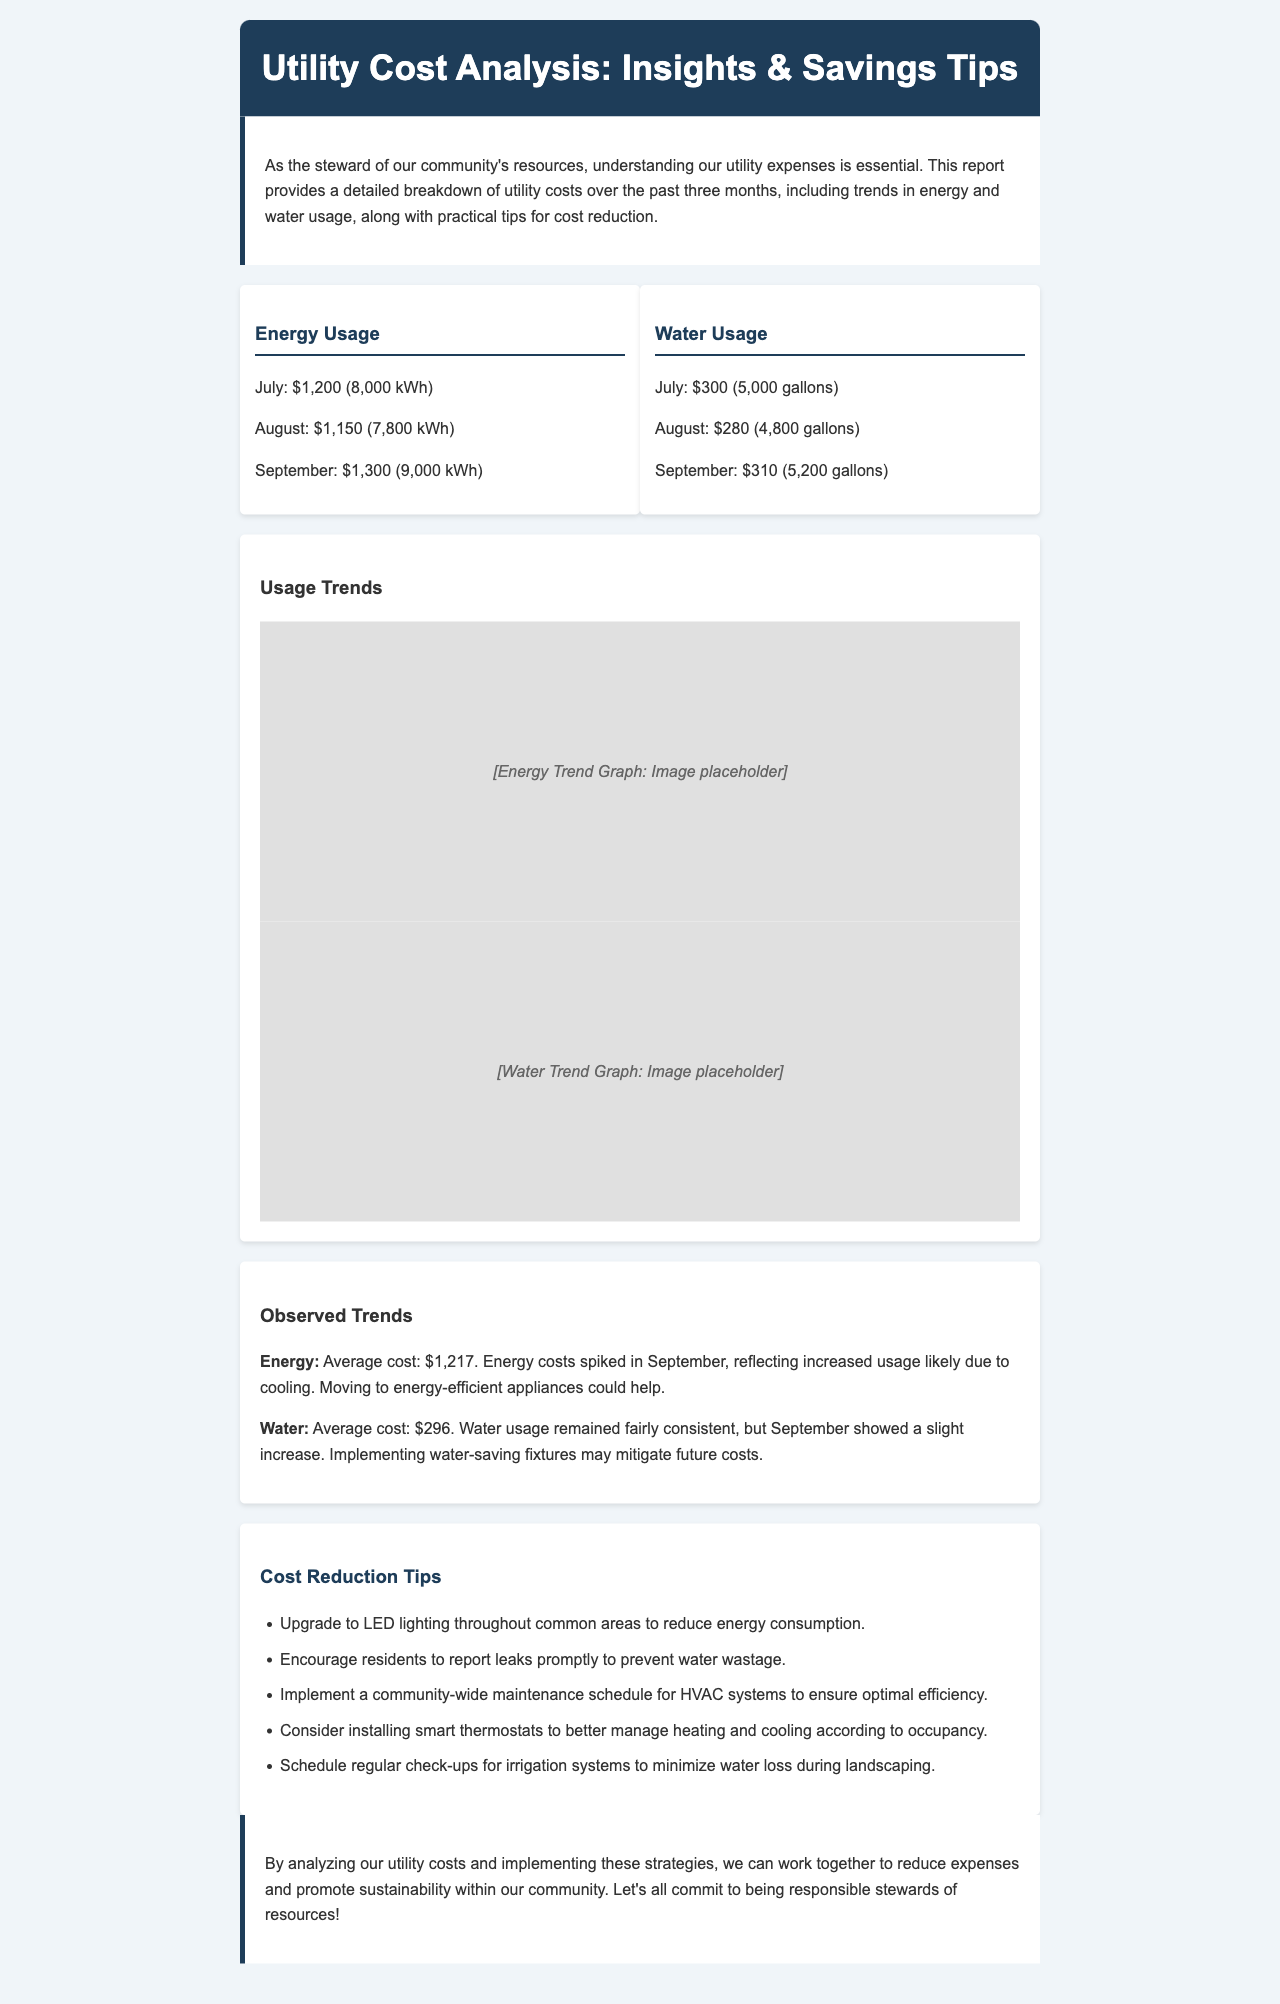What was the energy usage in July? The energy usage for July is detailed in the document as $1,200 for 8,000 kWh.
Answer: $1,200 What was the average water cost over the three months? To find the average water cost, sum up the July, August, and September costs ($300 + $280 + $310) and divide by three, giving $296.
Answer: $296 Which month had the highest energy cost? The document specifies the energy costs for each month and shows that September had the highest cost at $1,300.
Answer: September What is one suggested tip for reducing water costs? The document lists several tips for reducing costs, including encouraging residents to report leaks promptly, which helps prevent water wastage.
Answer: Report leaks promptly What is the average energy usage in kWh over the three months? The average energy usage is calculated by taking the sum of kWh for all three months (8,000 + 7,800 + 9,000) and dividing by three, resulting in an average of 8,267 kWh.
Answer: 8,267 kWh What color is the header background? The header background color is specified in the document as #1e3d59.
Answer: #1e3d59 What is one impact of increased energy usage noted in the trends section? The trends section indicates that the energy costs spiked in September likely due to increased cooling usage.
Answer: Increased cooling usage How many gallons were used in August? The document lists the water usage for August as 4,800 gallons.
Answer: 4,800 gallons What type of maintenance schedule is suggested for HVAC systems? A community-wide maintenance schedule is recommended to ensure optimal efficiency of HVAC systems.
Answer: Community-wide maintenance schedule 